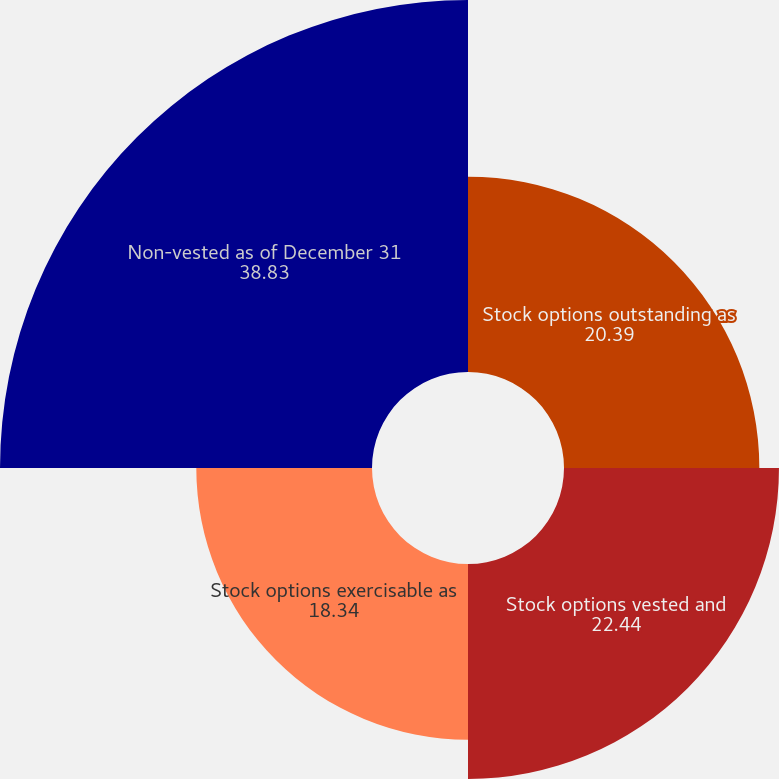Convert chart to OTSL. <chart><loc_0><loc_0><loc_500><loc_500><pie_chart><fcel>Stock options outstanding as<fcel>Stock options vested and<fcel>Stock options exercisable as<fcel>Non-vested as of December 31<nl><fcel>20.39%<fcel>22.44%<fcel>18.34%<fcel>38.83%<nl></chart> 